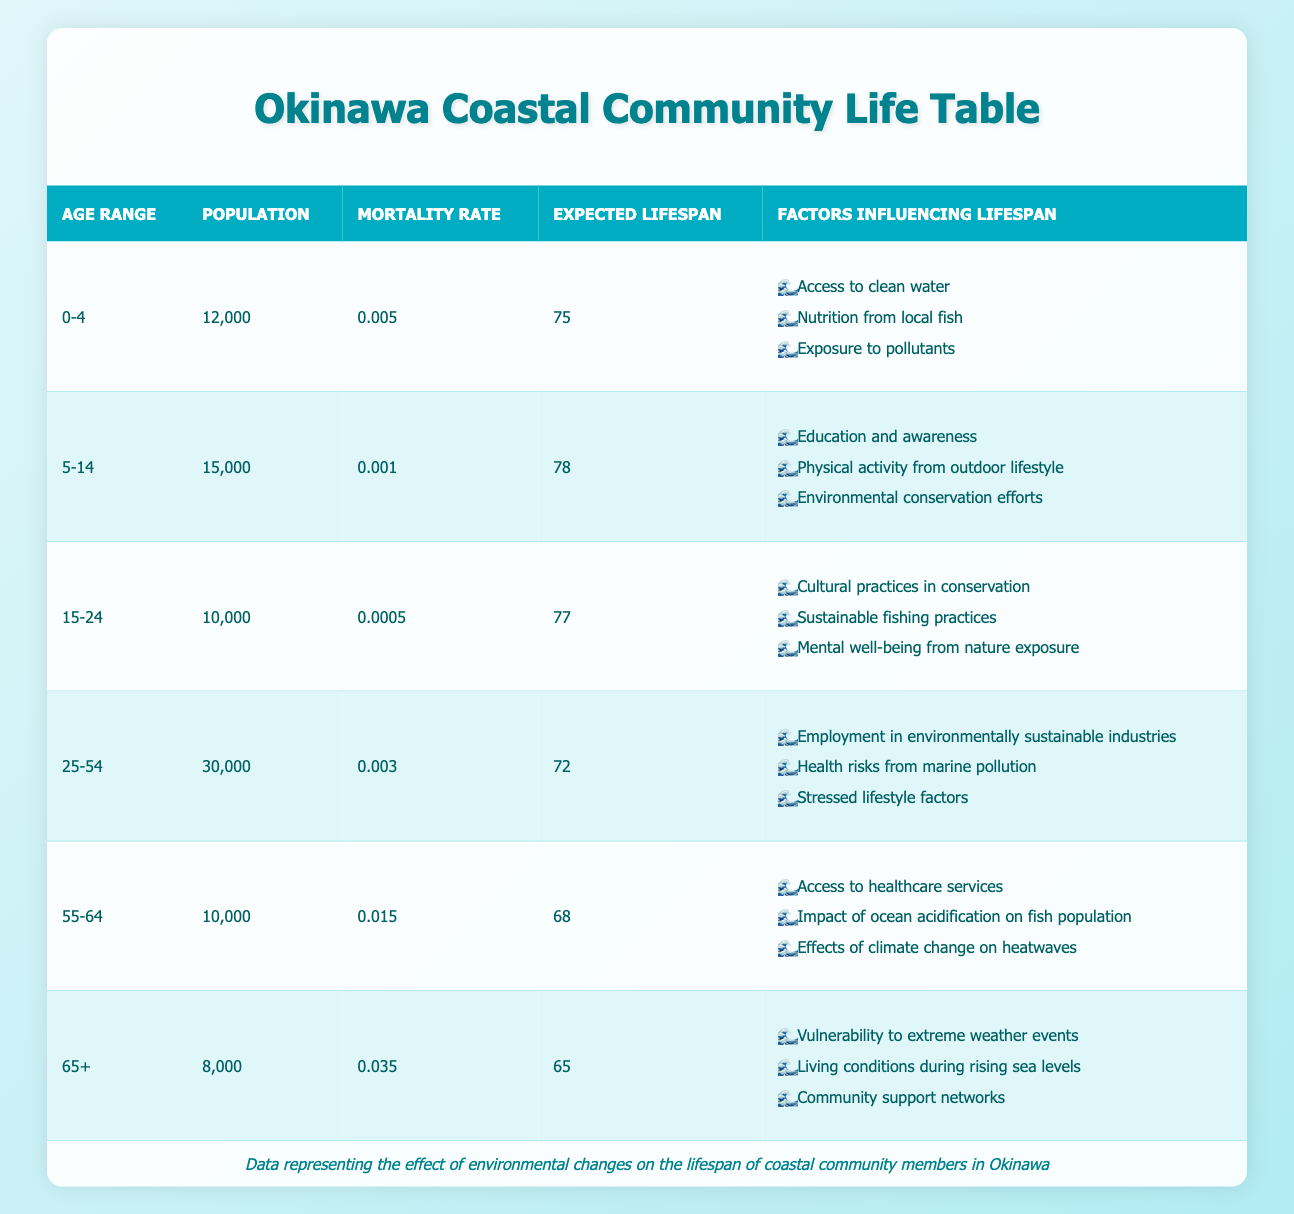What is the expected lifespan of individuals aged 55-64? According to the table, the expected lifespan for the age group 55-64 is listed directly as 68 years.
Answer: 68 How many individuals are in the age group 25-54? The population for the age group 25-54 is provided in the table as 30,000.
Answer: 30,000 What factors influence lifespan in the 0-4 age group? The table lists three factors affecting the lifespan of the 0-4 age group: Access to clean water, Nutrition from local fish, and Exposure to pollutants.
Answer: Access to clean water, Nutrition from local fish, Exposure to pollutants Is the mortality rate for the age group 15-24 lower than that of the age group 5-14? The mortality rate for 15-24 is 0.0005 and for 5-14 it is 0.001. Since 0.0005 is less than 0.001, the statement is true.
Answer: Yes What is the average expected lifespan of individuals across all age groups? To find the average expected lifespan, we add the expected lifespans for each age group (75 + 78 + 77 + 72 + 68 + 65 = 435) and divide by the number of age groups (6). Thus, 435/6 = 72.5, making the average expected lifespan approximately 72.5 years.
Answer: 72.5 How does the expected lifespan of the 65+ age group compare to the 0-4 age group? The expected lifespan for the 65+ age group is 65 years, while for the 0-4 age group it is 75 years. Since 65 is less than 75, the expected lifespan for the 65+ age group is lower.
Answer: Lower What are the total populations of individuals aged 25-54 and 55-64 combined? The population of 25-54 is 30,000 and the population of 55-64 is 10,000. Adding these together gives 30,000 + 10,000 = 40,000.
Answer: 40,000 Which age group has the highest mortality rate? By examining the mortality rates, the age group 65+ has the highest mortality rate of 0.035 when compared to the other groups.
Answer: 65+ What factors influence lifespan in the age group 25-54? The lifespan of the 25-54 age group is influenced by three factors listed in the table: Employment in environmentally sustainable industries, Health risks from marine pollution, and Stressed lifestyle factors.
Answer: Employment in environmentally sustainable industries, Health risks from marine pollution, Stressed lifestyle factors 